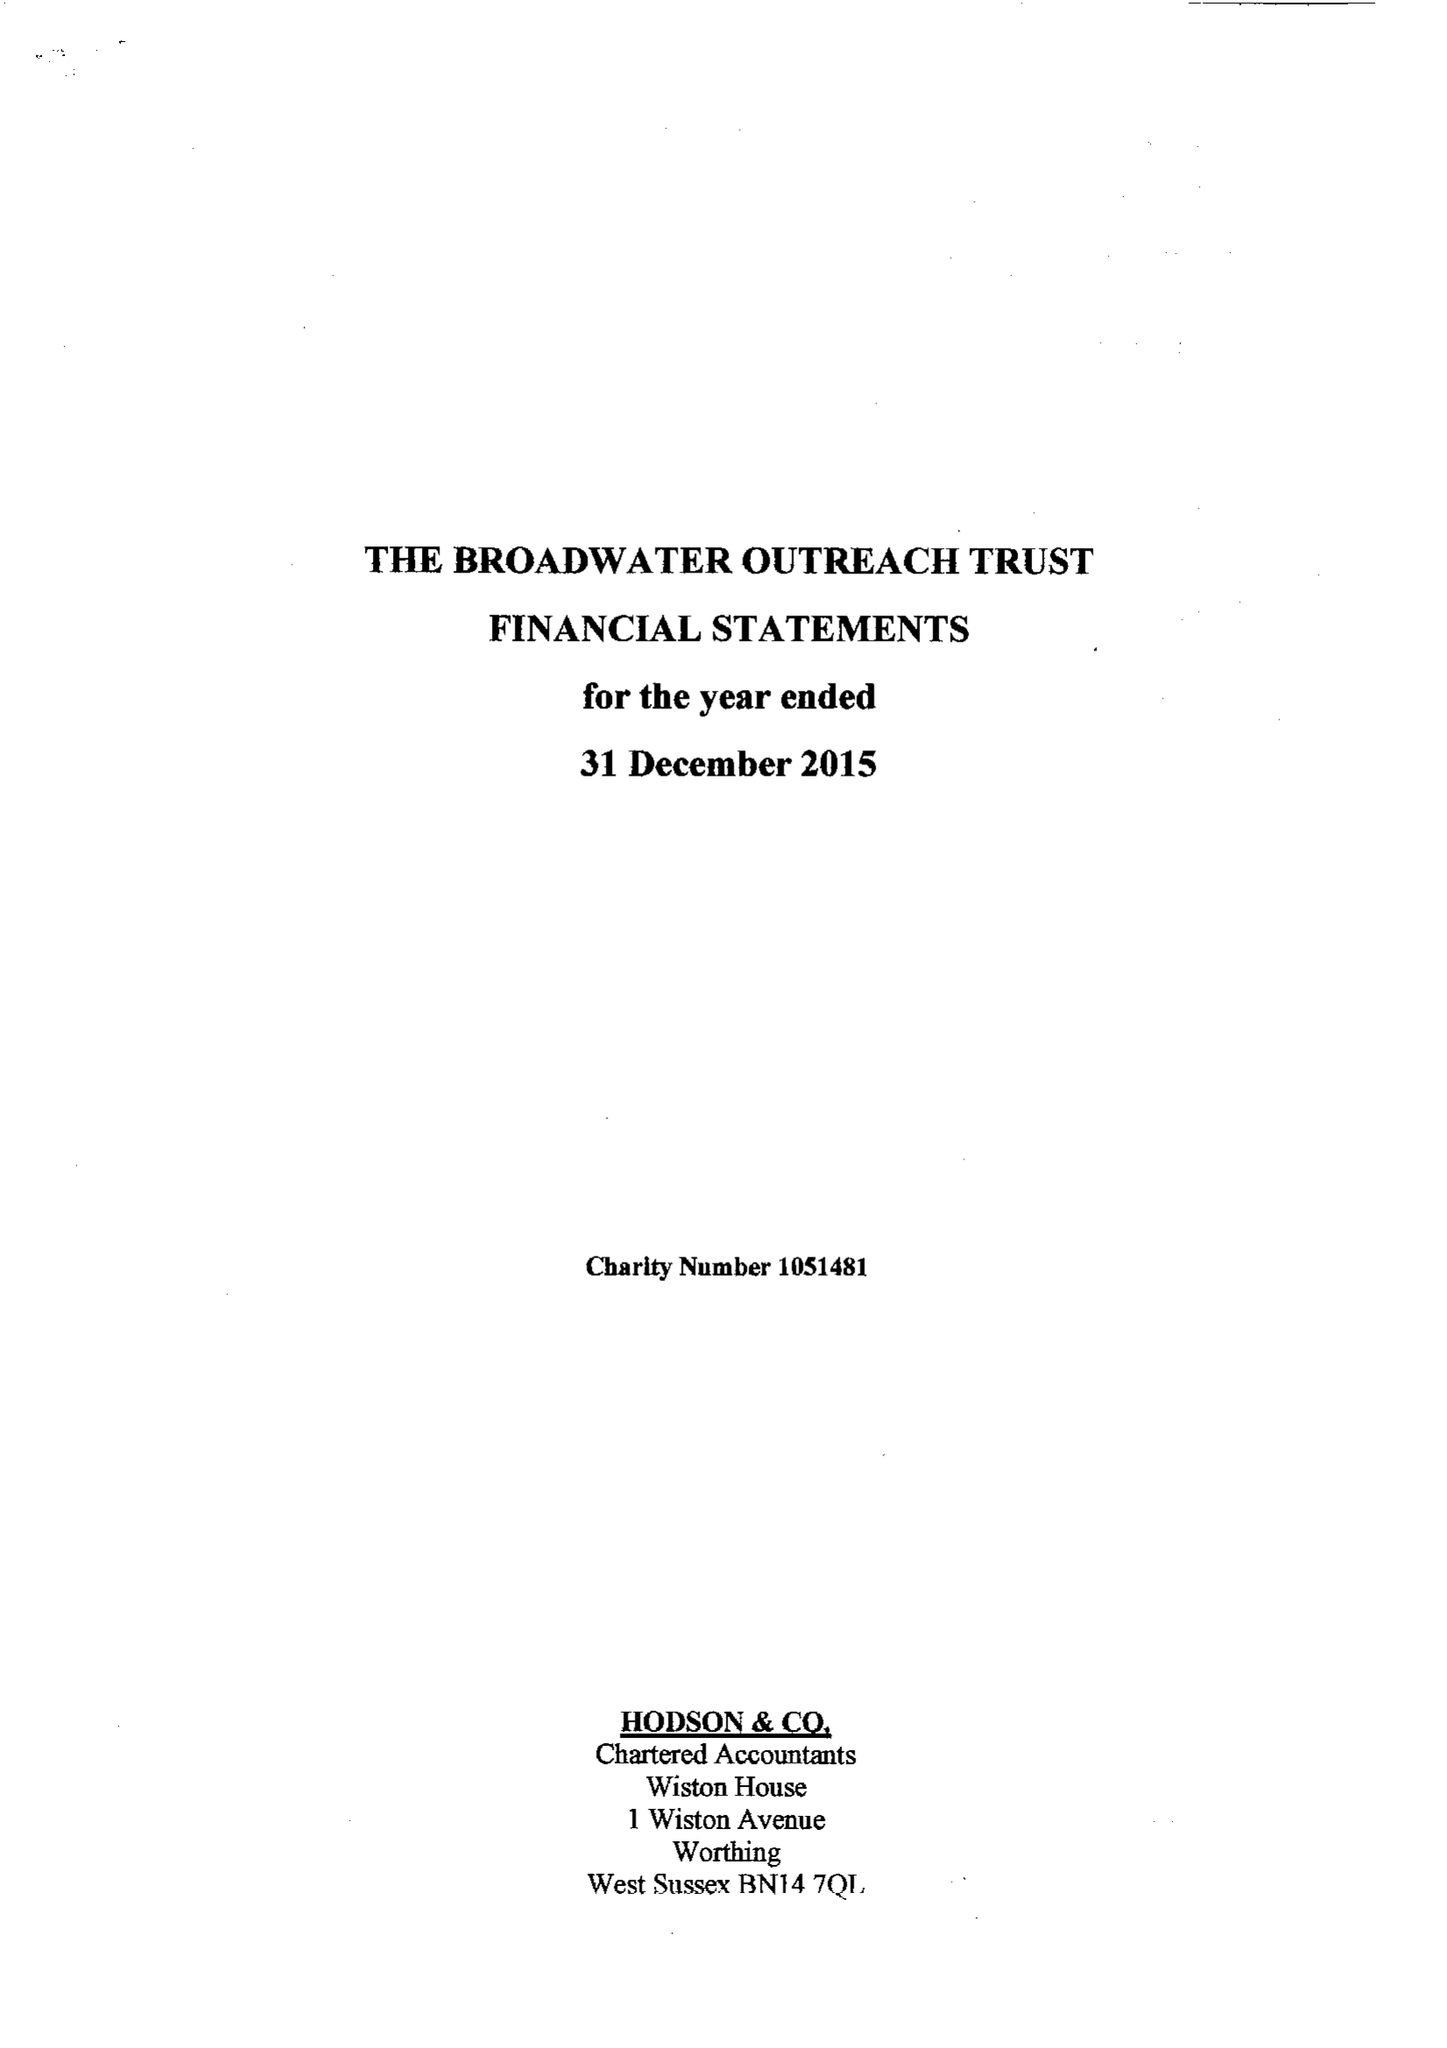What is the value for the report_date?
Answer the question using a single word or phrase. 2015-12-31 